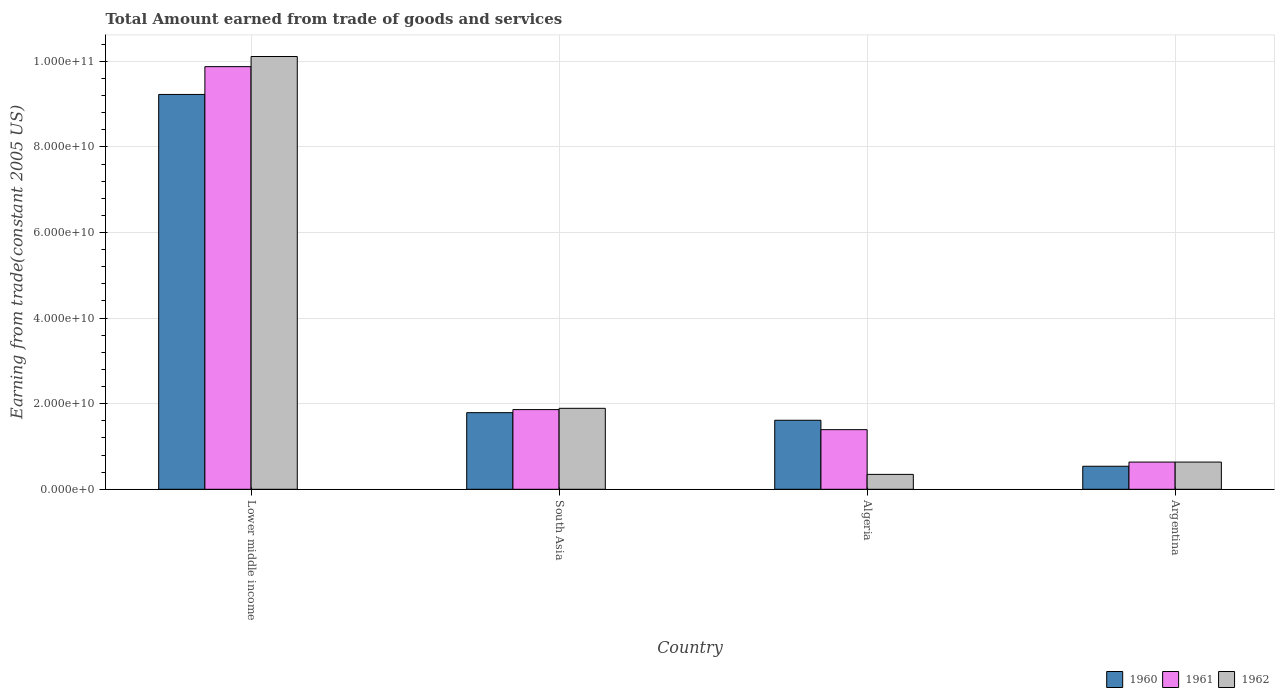How many groups of bars are there?
Ensure brevity in your answer.  4. Are the number of bars per tick equal to the number of legend labels?
Your answer should be very brief. Yes. How many bars are there on the 3rd tick from the left?
Make the answer very short. 3. In how many cases, is the number of bars for a given country not equal to the number of legend labels?
Keep it short and to the point. 0. What is the total amount earned by trading goods and services in 1962 in Algeria?
Give a very brief answer. 3.48e+09. Across all countries, what is the maximum total amount earned by trading goods and services in 1960?
Offer a very short reply. 9.23e+1. Across all countries, what is the minimum total amount earned by trading goods and services in 1962?
Offer a very short reply. 3.48e+09. In which country was the total amount earned by trading goods and services in 1962 maximum?
Your response must be concise. Lower middle income. In which country was the total amount earned by trading goods and services in 1962 minimum?
Ensure brevity in your answer.  Algeria. What is the total total amount earned by trading goods and services in 1960 in the graph?
Your response must be concise. 1.32e+11. What is the difference between the total amount earned by trading goods and services in 1962 in Argentina and that in Lower middle income?
Provide a succinct answer. -9.48e+1. What is the difference between the total amount earned by trading goods and services in 1961 in Argentina and the total amount earned by trading goods and services in 1960 in South Asia?
Provide a short and direct response. -1.15e+1. What is the average total amount earned by trading goods and services in 1962 per country?
Offer a terse response. 3.25e+1. What is the difference between the total amount earned by trading goods and services of/in 1961 and total amount earned by trading goods and services of/in 1962 in Lower middle income?
Ensure brevity in your answer.  -2.37e+09. What is the ratio of the total amount earned by trading goods and services in 1961 in Algeria to that in South Asia?
Your response must be concise. 0.75. Is the difference between the total amount earned by trading goods and services in 1961 in Lower middle income and South Asia greater than the difference between the total amount earned by trading goods and services in 1962 in Lower middle income and South Asia?
Your answer should be very brief. No. What is the difference between the highest and the second highest total amount earned by trading goods and services in 1961?
Provide a short and direct response. -4.69e+09. What is the difference between the highest and the lowest total amount earned by trading goods and services in 1961?
Ensure brevity in your answer.  9.24e+1. In how many countries, is the total amount earned by trading goods and services in 1962 greater than the average total amount earned by trading goods and services in 1962 taken over all countries?
Make the answer very short. 1. What does the 3rd bar from the left in Argentina represents?
Ensure brevity in your answer.  1962. What does the 1st bar from the right in Argentina represents?
Provide a short and direct response. 1962. Is it the case that in every country, the sum of the total amount earned by trading goods and services in 1961 and total amount earned by trading goods and services in 1960 is greater than the total amount earned by trading goods and services in 1962?
Your response must be concise. Yes. How many bars are there?
Give a very brief answer. 12. Are all the bars in the graph horizontal?
Give a very brief answer. No. How many countries are there in the graph?
Your response must be concise. 4. What is the difference between two consecutive major ticks on the Y-axis?
Your answer should be compact. 2.00e+1. Are the values on the major ticks of Y-axis written in scientific E-notation?
Give a very brief answer. Yes. How many legend labels are there?
Your answer should be compact. 3. How are the legend labels stacked?
Your answer should be very brief. Horizontal. What is the title of the graph?
Ensure brevity in your answer.  Total Amount earned from trade of goods and services. Does "1992" appear as one of the legend labels in the graph?
Your answer should be compact. No. What is the label or title of the Y-axis?
Your response must be concise. Earning from trade(constant 2005 US). What is the Earning from trade(constant 2005 US) of 1960 in Lower middle income?
Your answer should be compact. 9.23e+1. What is the Earning from trade(constant 2005 US) of 1961 in Lower middle income?
Offer a very short reply. 9.88e+1. What is the Earning from trade(constant 2005 US) of 1962 in Lower middle income?
Your answer should be compact. 1.01e+11. What is the Earning from trade(constant 2005 US) of 1960 in South Asia?
Give a very brief answer. 1.79e+1. What is the Earning from trade(constant 2005 US) of 1961 in South Asia?
Provide a short and direct response. 1.86e+1. What is the Earning from trade(constant 2005 US) in 1962 in South Asia?
Make the answer very short. 1.89e+1. What is the Earning from trade(constant 2005 US) of 1960 in Algeria?
Keep it short and to the point. 1.61e+1. What is the Earning from trade(constant 2005 US) in 1961 in Algeria?
Your response must be concise. 1.39e+1. What is the Earning from trade(constant 2005 US) in 1962 in Algeria?
Offer a terse response. 3.48e+09. What is the Earning from trade(constant 2005 US) in 1960 in Argentina?
Give a very brief answer. 5.38e+09. What is the Earning from trade(constant 2005 US) in 1961 in Argentina?
Offer a terse response. 6.36e+09. What is the Earning from trade(constant 2005 US) of 1962 in Argentina?
Your response must be concise. 6.36e+09. Across all countries, what is the maximum Earning from trade(constant 2005 US) of 1960?
Your answer should be very brief. 9.23e+1. Across all countries, what is the maximum Earning from trade(constant 2005 US) of 1961?
Your answer should be compact. 9.88e+1. Across all countries, what is the maximum Earning from trade(constant 2005 US) in 1962?
Give a very brief answer. 1.01e+11. Across all countries, what is the minimum Earning from trade(constant 2005 US) of 1960?
Offer a very short reply. 5.38e+09. Across all countries, what is the minimum Earning from trade(constant 2005 US) of 1961?
Keep it short and to the point. 6.36e+09. Across all countries, what is the minimum Earning from trade(constant 2005 US) in 1962?
Keep it short and to the point. 3.48e+09. What is the total Earning from trade(constant 2005 US) of 1960 in the graph?
Your answer should be very brief. 1.32e+11. What is the total Earning from trade(constant 2005 US) in 1961 in the graph?
Your response must be concise. 1.38e+11. What is the total Earning from trade(constant 2005 US) in 1962 in the graph?
Your response must be concise. 1.30e+11. What is the difference between the Earning from trade(constant 2005 US) in 1960 in Lower middle income and that in South Asia?
Provide a succinct answer. 7.44e+1. What is the difference between the Earning from trade(constant 2005 US) of 1961 in Lower middle income and that in South Asia?
Offer a terse response. 8.01e+1. What is the difference between the Earning from trade(constant 2005 US) in 1962 in Lower middle income and that in South Asia?
Provide a succinct answer. 8.22e+1. What is the difference between the Earning from trade(constant 2005 US) in 1960 in Lower middle income and that in Algeria?
Offer a terse response. 7.61e+1. What is the difference between the Earning from trade(constant 2005 US) of 1961 in Lower middle income and that in Algeria?
Your answer should be very brief. 8.48e+1. What is the difference between the Earning from trade(constant 2005 US) in 1962 in Lower middle income and that in Algeria?
Provide a short and direct response. 9.76e+1. What is the difference between the Earning from trade(constant 2005 US) in 1960 in Lower middle income and that in Argentina?
Provide a short and direct response. 8.69e+1. What is the difference between the Earning from trade(constant 2005 US) in 1961 in Lower middle income and that in Argentina?
Provide a succinct answer. 9.24e+1. What is the difference between the Earning from trade(constant 2005 US) of 1962 in Lower middle income and that in Argentina?
Your response must be concise. 9.48e+1. What is the difference between the Earning from trade(constant 2005 US) in 1960 in South Asia and that in Algeria?
Provide a succinct answer. 1.77e+09. What is the difference between the Earning from trade(constant 2005 US) of 1961 in South Asia and that in Algeria?
Ensure brevity in your answer.  4.69e+09. What is the difference between the Earning from trade(constant 2005 US) of 1962 in South Asia and that in Algeria?
Offer a terse response. 1.54e+1. What is the difference between the Earning from trade(constant 2005 US) in 1960 in South Asia and that in Argentina?
Make the answer very short. 1.25e+1. What is the difference between the Earning from trade(constant 2005 US) of 1961 in South Asia and that in Argentina?
Your response must be concise. 1.23e+1. What is the difference between the Earning from trade(constant 2005 US) of 1962 in South Asia and that in Argentina?
Your answer should be very brief. 1.26e+1. What is the difference between the Earning from trade(constant 2005 US) in 1960 in Algeria and that in Argentina?
Provide a short and direct response. 1.08e+1. What is the difference between the Earning from trade(constant 2005 US) in 1961 in Algeria and that in Argentina?
Your answer should be very brief. 7.57e+09. What is the difference between the Earning from trade(constant 2005 US) of 1962 in Algeria and that in Argentina?
Provide a succinct answer. -2.88e+09. What is the difference between the Earning from trade(constant 2005 US) of 1960 in Lower middle income and the Earning from trade(constant 2005 US) of 1961 in South Asia?
Keep it short and to the point. 7.36e+1. What is the difference between the Earning from trade(constant 2005 US) of 1960 in Lower middle income and the Earning from trade(constant 2005 US) of 1962 in South Asia?
Keep it short and to the point. 7.33e+1. What is the difference between the Earning from trade(constant 2005 US) of 1961 in Lower middle income and the Earning from trade(constant 2005 US) of 1962 in South Asia?
Offer a terse response. 7.98e+1. What is the difference between the Earning from trade(constant 2005 US) of 1960 in Lower middle income and the Earning from trade(constant 2005 US) of 1961 in Algeria?
Offer a terse response. 7.83e+1. What is the difference between the Earning from trade(constant 2005 US) in 1960 in Lower middle income and the Earning from trade(constant 2005 US) in 1962 in Algeria?
Provide a short and direct response. 8.88e+1. What is the difference between the Earning from trade(constant 2005 US) in 1961 in Lower middle income and the Earning from trade(constant 2005 US) in 1962 in Algeria?
Your answer should be very brief. 9.53e+1. What is the difference between the Earning from trade(constant 2005 US) in 1960 in Lower middle income and the Earning from trade(constant 2005 US) in 1961 in Argentina?
Ensure brevity in your answer.  8.59e+1. What is the difference between the Earning from trade(constant 2005 US) in 1960 in Lower middle income and the Earning from trade(constant 2005 US) in 1962 in Argentina?
Your response must be concise. 8.59e+1. What is the difference between the Earning from trade(constant 2005 US) in 1961 in Lower middle income and the Earning from trade(constant 2005 US) in 1962 in Argentina?
Your answer should be compact. 9.24e+1. What is the difference between the Earning from trade(constant 2005 US) of 1960 in South Asia and the Earning from trade(constant 2005 US) of 1961 in Algeria?
Your answer should be very brief. 3.97e+09. What is the difference between the Earning from trade(constant 2005 US) of 1960 in South Asia and the Earning from trade(constant 2005 US) of 1962 in Algeria?
Provide a succinct answer. 1.44e+1. What is the difference between the Earning from trade(constant 2005 US) in 1961 in South Asia and the Earning from trade(constant 2005 US) in 1962 in Algeria?
Ensure brevity in your answer.  1.51e+1. What is the difference between the Earning from trade(constant 2005 US) in 1960 in South Asia and the Earning from trade(constant 2005 US) in 1961 in Argentina?
Your answer should be compact. 1.15e+1. What is the difference between the Earning from trade(constant 2005 US) of 1960 in South Asia and the Earning from trade(constant 2005 US) of 1962 in Argentina?
Your answer should be compact. 1.15e+1. What is the difference between the Earning from trade(constant 2005 US) in 1961 in South Asia and the Earning from trade(constant 2005 US) in 1962 in Argentina?
Offer a very short reply. 1.23e+1. What is the difference between the Earning from trade(constant 2005 US) of 1960 in Algeria and the Earning from trade(constant 2005 US) of 1961 in Argentina?
Give a very brief answer. 9.77e+09. What is the difference between the Earning from trade(constant 2005 US) of 1960 in Algeria and the Earning from trade(constant 2005 US) of 1962 in Argentina?
Make the answer very short. 9.77e+09. What is the difference between the Earning from trade(constant 2005 US) in 1961 in Algeria and the Earning from trade(constant 2005 US) in 1962 in Argentina?
Make the answer very short. 7.57e+09. What is the average Earning from trade(constant 2005 US) in 1960 per country?
Ensure brevity in your answer.  3.29e+1. What is the average Earning from trade(constant 2005 US) in 1961 per country?
Provide a succinct answer. 3.44e+1. What is the average Earning from trade(constant 2005 US) in 1962 per country?
Your answer should be very brief. 3.25e+1. What is the difference between the Earning from trade(constant 2005 US) of 1960 and Earning from trade(constant 2005 US) of 1961 in Lower middle income?
Offer a terse response. -6.49e+09. What is the difference between the Earning from trade(constant 2005 US) of 1960 and Earning from trade(constant 2005 US) of 1962 in Lower middle income?
Provide a succinct answer. -8.86e+09. What is the difference between the Earning from trade(constant 2005 US) of 1961 and Earning from trade(constant 2005 US) of 1962 in Lower middle income?
Give a very brief answer. -2.37e+09. What is the difference between the Earning from trade(constant 2005 US) of 1960 and Earning from trade(constant 2005 US) of 1961 in South Asia?
Provide a short and direct response. -7.18e+08. What is the difference between the Earning from trade(constant 2005 US) in 1960 and Earning from trade(constant 2005 US) in 1962 in South Asia?
Your answer should be very brief. -1.02e+09. What is the difference between the Earning from trade(constant 2005 US) of 1961 and Earning from trade(constant 2005 US) of 1962 in South Asia?
Your response must be concise. -3.00e+08. What is the difference between the Earning from trade(constant 2005 US) of 1960 and Earning from trade(constant 2005 US) of 1961 in Algeria?
Provide a succinct answer. 2.20e+09. What is the difference between the Earning from trade(constant 2005 US) of 1960 and Earning from trade(constant 2005 US) of 1962 in Algeria?
Your answer should be compact. 1.26e+1. What is the difference between the Earning from trade(constant 2005 US) of 1961 and Earning from trade(constant 2005 US) of 1962 in Algeria?
Your response must be concise. 1.04e+1. What is the difference between the Earning from trade(constant 2005 US) in 1960 and Earning from trade(constant 2005 US) in 1961 in Argentina?
Provide a short and direct response. -9.78e+08. What is the difference between the Earning from trade(constant 2005 US) in 1960 and Earning from trade(constant 2005 US) in 1962 in Argentina?
Make the answer very short. -9.78e+08. What is the difference between the Earning from trade(constant 2005 US) of 1961 and Earning from trade(constant 2005 US) of 1962 in Argentina?
Provide a short and direct response. 0. What is the ratio of the Earning from trade(constant 2005 US) in 1960 in Lower middle income to that in South Asia?
Your answer should be very brief. 5.15. What is the ratio of the Earning from trade(constant 2005 US) in 1961 in Lower middle income to that in South Asia?
Provide a short and direct response. 5.3. What is the ratio of the Earning from trade(constant 2005 US) in 1962 in Lower middle income to that in South Asia?
Keep it short and to the point. 5.34. What is the ratio of the Earning from trade(constant 2005 US) of 1960 in Lower middle income to that in Algeria?
Give a very brief answer. 5.72. What is the ratio of the Earning from trade(constant 2005 US) in 1961 in Lower middle income to that in Algeria?
Your response must be concise. 7.09. What is the ratio of the Earning from trade(constant 2005 US) in 1962 in Lower middle income to that in Algeria?
Keep it short and to the point. 29.03. What is the ratio of the Earning from trade(constant 2005 US) of 1960 in Lower middle income to that in Argentina?
Provide a short and direct response. 17.14. What is the ratio of the Earning from trade(constant 2005 US) in 1961 in Lower middle income to that in Argentina?
Offer a very short reply. 15.53. What is the ratio of the Earning from trade(constant 2005 US) of 1962 in Lower middle income to that in Argentina?
Provide a succinct answer. 15.9. What is the ratio of the Earning from trade(constant 2005 US) in 1960 in South Asia to that in Algeria?
Your answer should be compact. 1.11. What is the ratio of the Earning from trade(constant 2005 US) of 1961 in South Asia to that in Algeria?
Keep it short and to the point. 1.34. What is the ratio of the Earning from trade(constant 2005 US) in 1962 in South Asia to that in Algeria?
Provide a succinct answer. 5.43. What is the ratio of the Earning from trade(constant 2005 US) in 1960 in South Asia to that in Argentina?
Offer a very short reply. 3.33. What is the ratio of the Earning from trade(constant 2005 US) in 1961 in South Asia to that in Argentina?
Offer a very short reply. 2.93. What is the ratio of the Earning from trade(constant 2005 US) in 1962 in South Asia to that in Argentina?
Ensure brevity in your answer.  2.98. What is the ratio of the Earning from trade(constant 2005 US) of 1960 in Algeria to that in Argentina?
Your answer should be compact. 3. What is the ratio of the Earning from trade(constant 2005 US) of 1961 in Algeria to that in Argentina?
Ensure brevity in your answer.  2.19. What is the ratio of the Earning from trade(constant 2005 US) of 1962 in Algeria to that in Argentina?
Give a very brief answer. 0.55. What is the difference between the highest and the second highest Earning from trade(constant 2005 US) of 1960?
Your answer should be compact. 7.44e+1. What is the difference between the highest and the second highest Earning from trade(constant 2005 US) of 1961?
Your answer should be very brief. 8.01e+1. What is the difference between the highest and the second highest Earning from trade(constant 2005 US) of 1962?
Offer a very short reply. 8.22e+1. What is the difference between the highest and the lowest Earning from trade(constant 2005 US) in 1960?
Your response must be concise. 8.69e+1. What is the difference between the highest and the lowest Earning from trade(constant 2005 US) in 1961?
Your answer should be very brief. 9.24e+1. What is the difference between the highest and the lowest Earning from trade(constant 2005 US) in 1962?
Offer a terse response. 9.76e+1. 